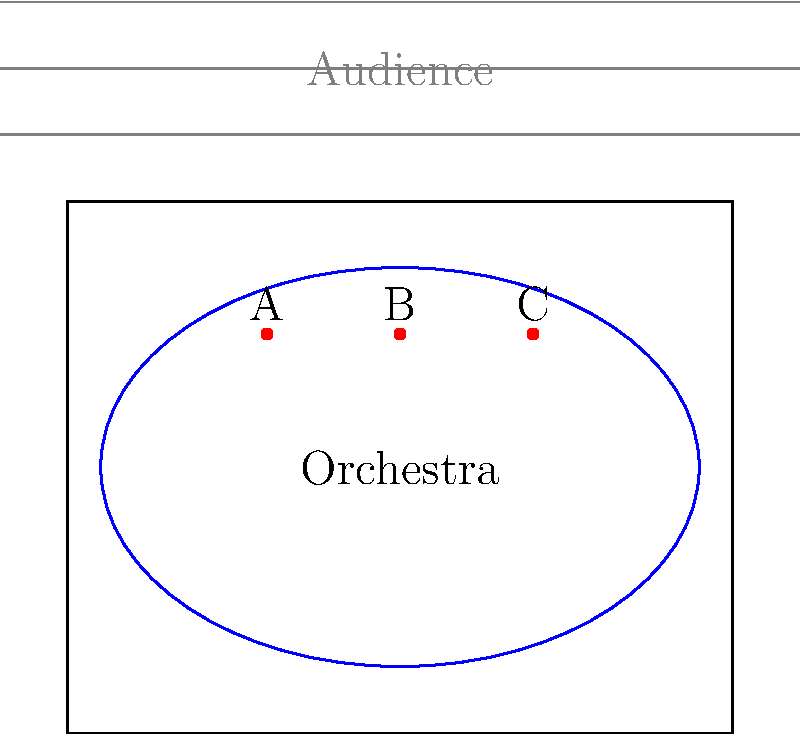Based on the stage layout shown, which podium position (A, B, or C) would be most effective for a conductor to maintain optimal visual contact with both the orchestra and the audience? To determine the optimal podium placement, we need to consider the following factors:

1. Visibility to the orchestra: The conductor needs to have a clear view of all orchestra members.
2. Visibility to the audience: The conductor should be visible to the audience for engagement.
3. Centrality: A central position allows for better control and communication.

Let's analyze each position:

A. Left position (3,6):
   - Good view of the right side of the orchestra
   - Partially obscured view of the left side
   - Off-center, may be difficult for left-side audience to see

B. Center position (5,6):
   - Excellent view of the entire orchestra
   - Centered for the audience
   - Optimal for gestures and communication with all sections

C. Right position (7,6):
   - Good view of the left side of the orchestra
   - Partially obscured view of the right side
   - Off-center, may be difficult for right-side audience to see

Considering these factors, position B (center) provides the best balance of visibility and centrality. It allows the conductor to:

1. See all orchestra members clearly
2. Be easily visible to the entire audience
3. Maintain a central position for optimal control and communication

Therefore, position B is the most effective for maintaining optimal visual contact with both the orchestra and the audience.
Answer: B 